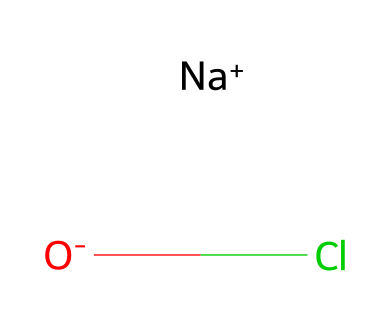What is the name of the compound represented by this SMILES? The SMILES notation [Na+].[O-]Cl indicates the presence of sodium, oxygen, and chlorine, which combine to form sodium hypochlorite.
Answer: sodium hypochlorite How many atoms are present in this chemical structure? Counting the atoms in the SMILES, there are two sodium-related atoms (one sodium ion and one oxygen atom) and one chlorine atom, totaling three atoms.
Answer: three What type of bonding exists between the chlorine and oxygen in sodium hypochlorite? In the SMILES notation, the bond between chlorine and oxygen is a covalent bond, as both elements share electrons to form the compound.
Answer: covalent Is sodium hypochlorite a hypervalent compound? Sodium hypochlorite does not contain any central atom that exceeds the octet rule; it is not hypervalent as it follows standard valency for the elements involved.
Answer: no What is the oxidation state of chlorine in sodium hypochlorite? In sodium hypochlorite, chlorine has an oxidation state of +1, derived from the overall charge balance in the compound.
Answer: +1 What role does sodium play in this chemical structure? Sodium in this compound acts as a counterion, balancing the charge of the hypochlorite ion (OCl-).
Answer: counterion Can sodium hypochlorite be classified as an ionic compound? Given the presence of sodium as a cation and hypochlorite as an anion, sodium hypochlorite is best classified as an ionic compound.
Answer: yes 